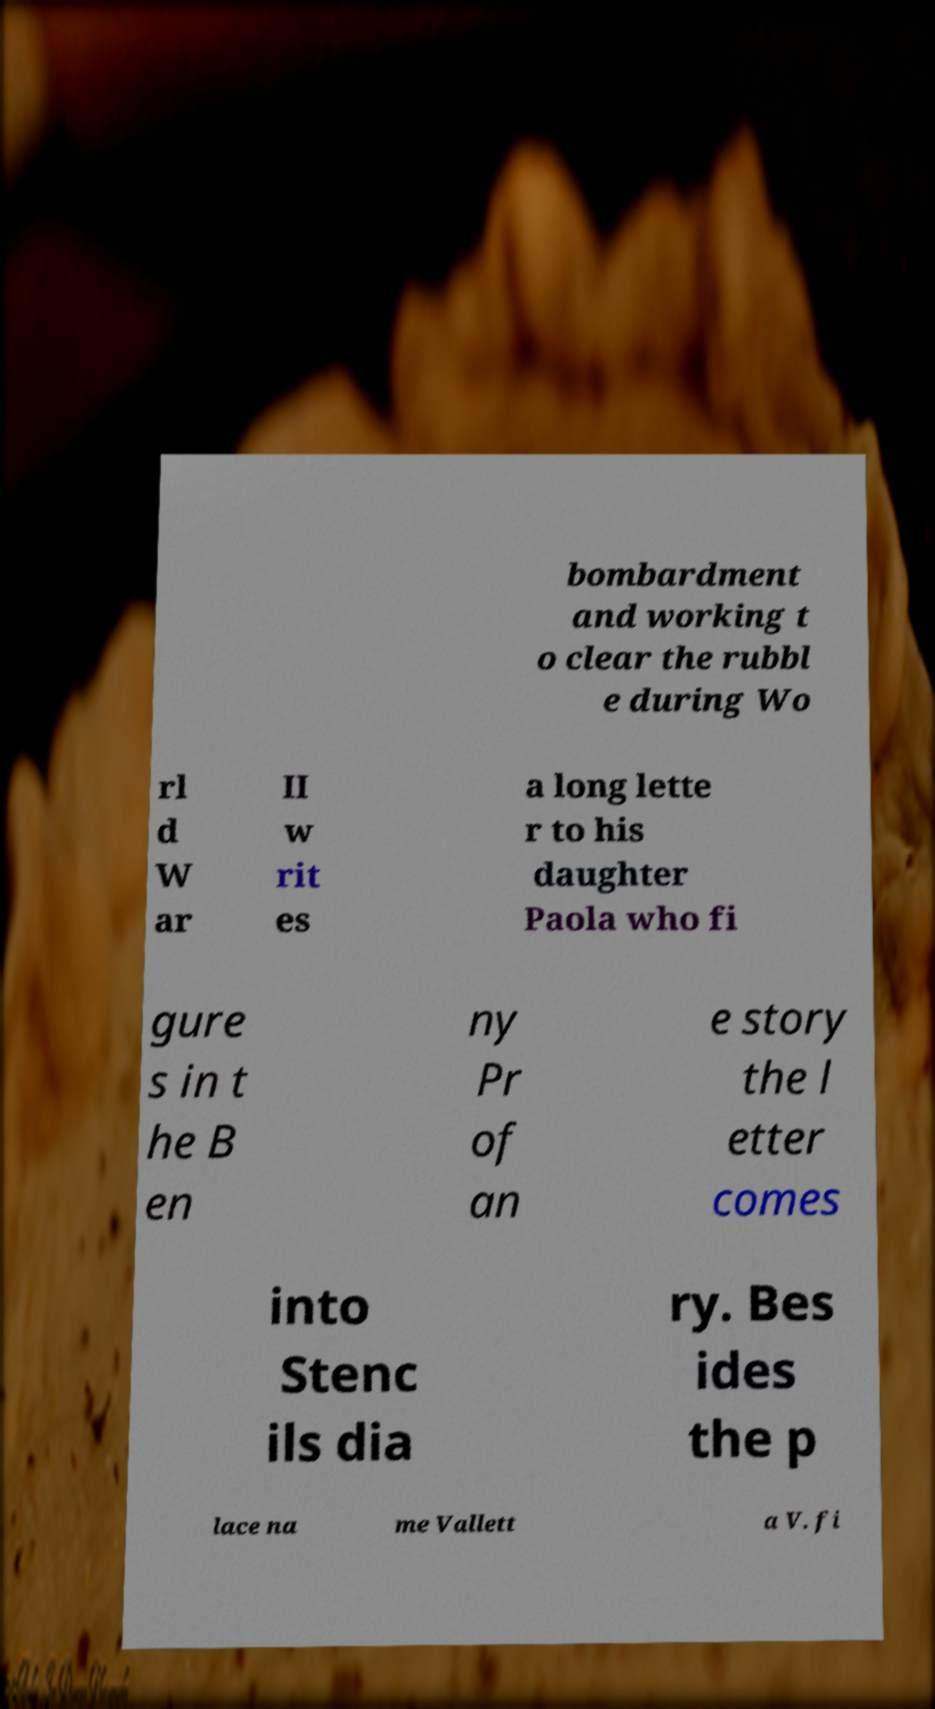Can you accurately transcribe the text from the provided image for me? bombardment and working t o clear the rubbl e during Wo rl d W ar II w rit es a long lette r to his daughter Paola who fi gure s in t he B en ny Pr of an e story the l etter comes into Stenc ils dia ry. Bes ides the p lace na me Vallett a V. fi 